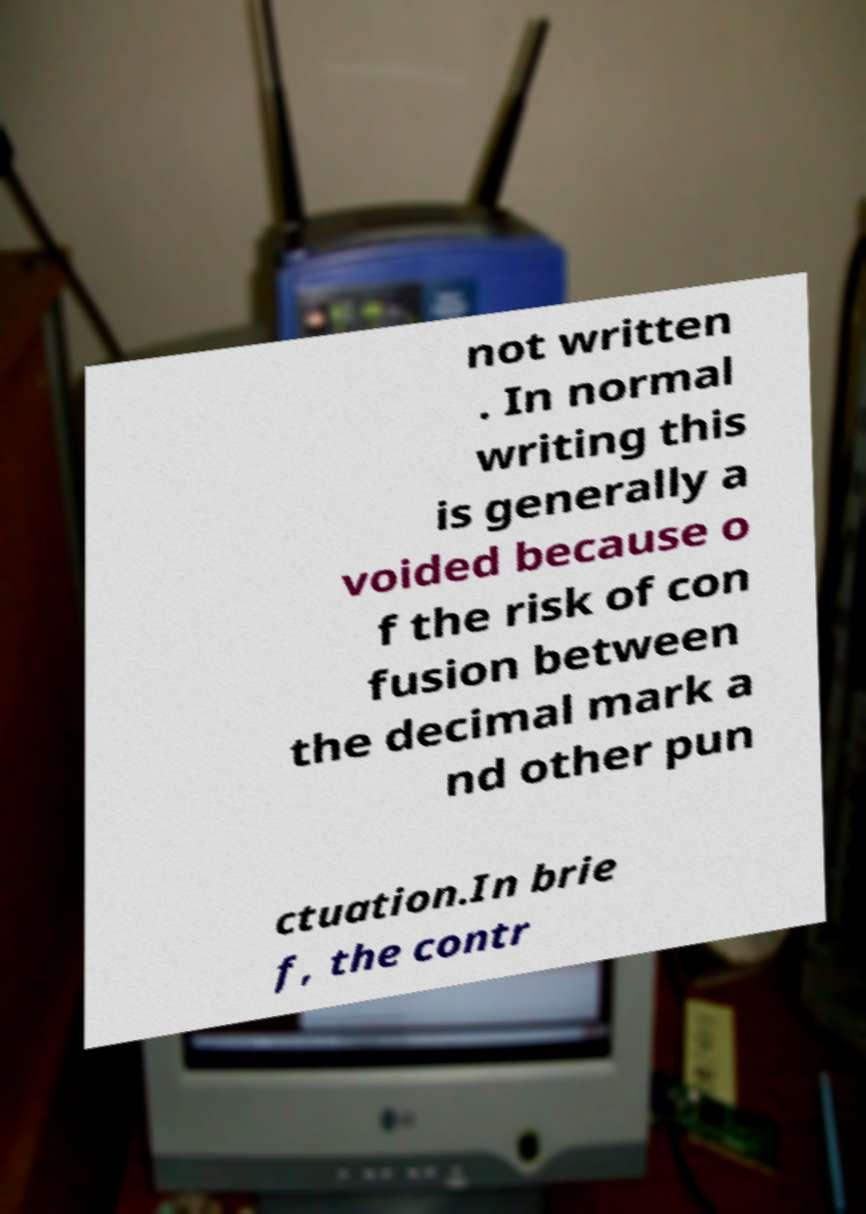What messages or text are displayed in this image? I need them in a readable, typed format. not written . In normal writing this is generally a voided because o f the risk of con fusion between the decimal mark a nd other pun ctuation.In brie f, the contr 